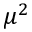Convert formula to latex. <formula><loc_0><loc_0><loc_500><loc_500>\mu ^ { 2 }</formula> 